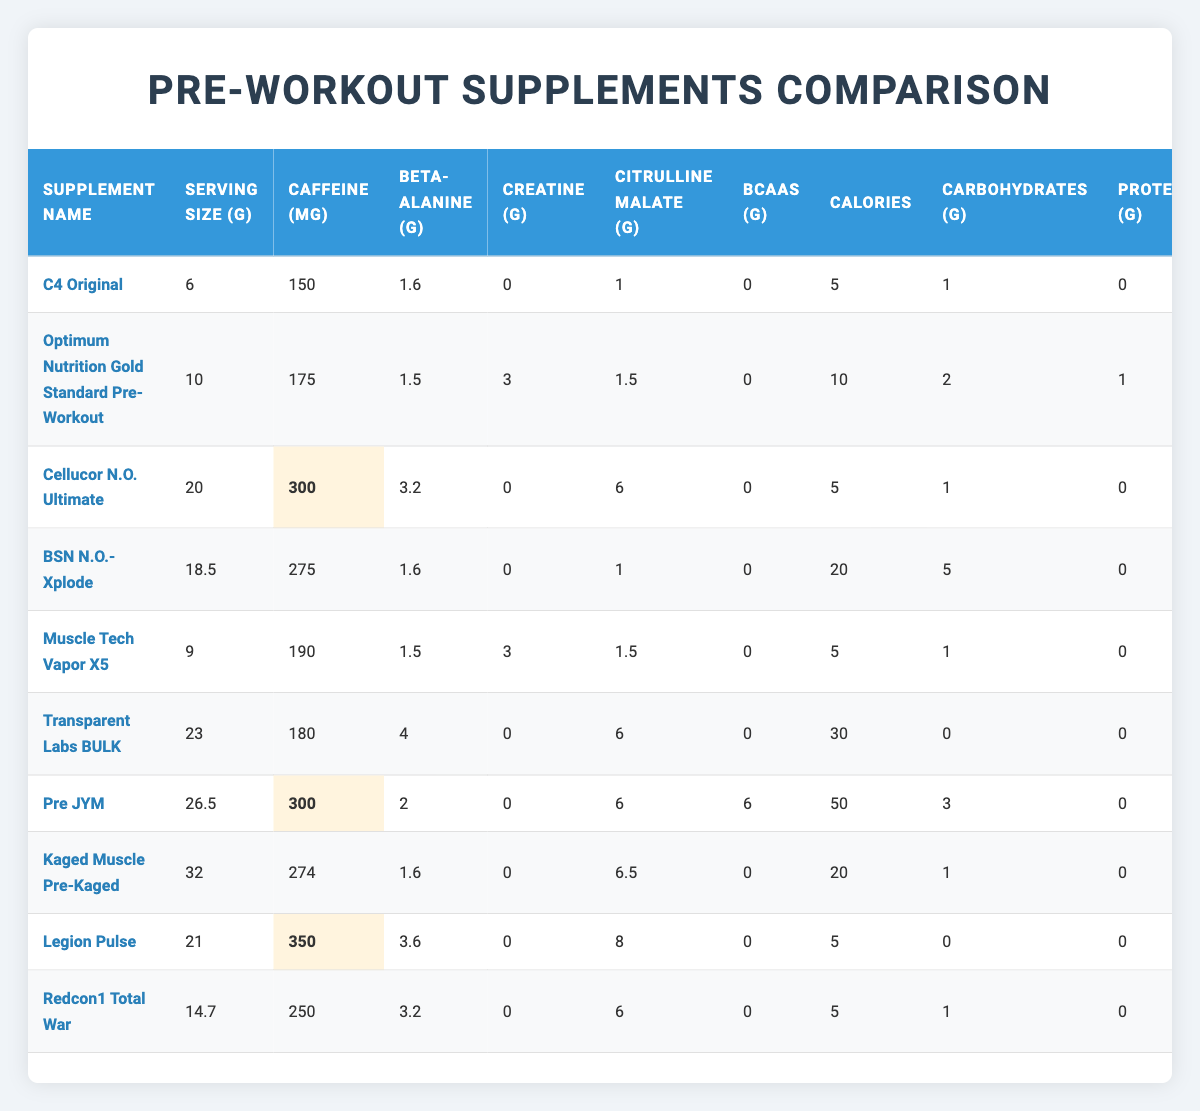What is the caffeine content of C4 Original? The table lists C4 Original with a caffeine content of 150 mg in the column for caffeine.
Answer: 150 mg Which supplement has the highest Beta-Alanine content? The table shows that Beta-Alanine content is highest in Transparent Labs BULK, with 4 g.
Answer: Transparent Labs BULK How many calories does Pre JYM contain? Pre JYM has a calorie content of 50, as indicated in the calories column of the table.
Answer: 50 What is the total Creatine content in Optimum Nutrition Gold Standard Pre-Workout and Muscle Tech Vapor X5 combined? Optimum Nutrition has 3 g and Muscle Tech has 3 g of Creatine. Adding them together gives 3 + 3 = 6 g.
Answer: 6 g Do all supplements contain protein? The table shows that supplements like C4 Original and BSN N.O.-Xplode have 0 g of protein, so not all contain protein.
Answer: No Which supplement has the lowest serving size? Upon checking the serving sizes, C4 Original has the lowest at 6 g.
Answer: C4 Original On average, how much caffeine do the supplements provide? The caffeine content of the supplements is 150, 175, 300, 275, 190, 180, 300, 274, 350, and 250 mg, which sums to 2499 mg. There are 10 supplements, so the average is 2499 / 10 = 249.9 mg.
Answer: 249.9 mg Which supplement contains the most carbohydrates? When comparing the carbohydrate content, Pre JYM has the highest at 6 g.
Answer: Pre JYM How many supplements have more than 200 mg of caffeine? The table shows that Cellucor N.O. Ultimate, BSN N.O.-Xplode, Pre JYM, Legion Pulse, and Redcon1 Total War have caffeine amounts greater than 200 mg, totaling 5 supplements.
Answer: 5 What is the total amount of Citrulline Malate in the three highest Citrulline Malate supplements? The top three supplements are: Pre JYM (6.5 g), Legion Pulse (8 g), and Optimum Nutrition Gold Standard Pre-Workout (1.5 g). Summing them 6.5 + 8 + 1.5 = 16 g of Citrulline Malate.
Answer: 16 g 